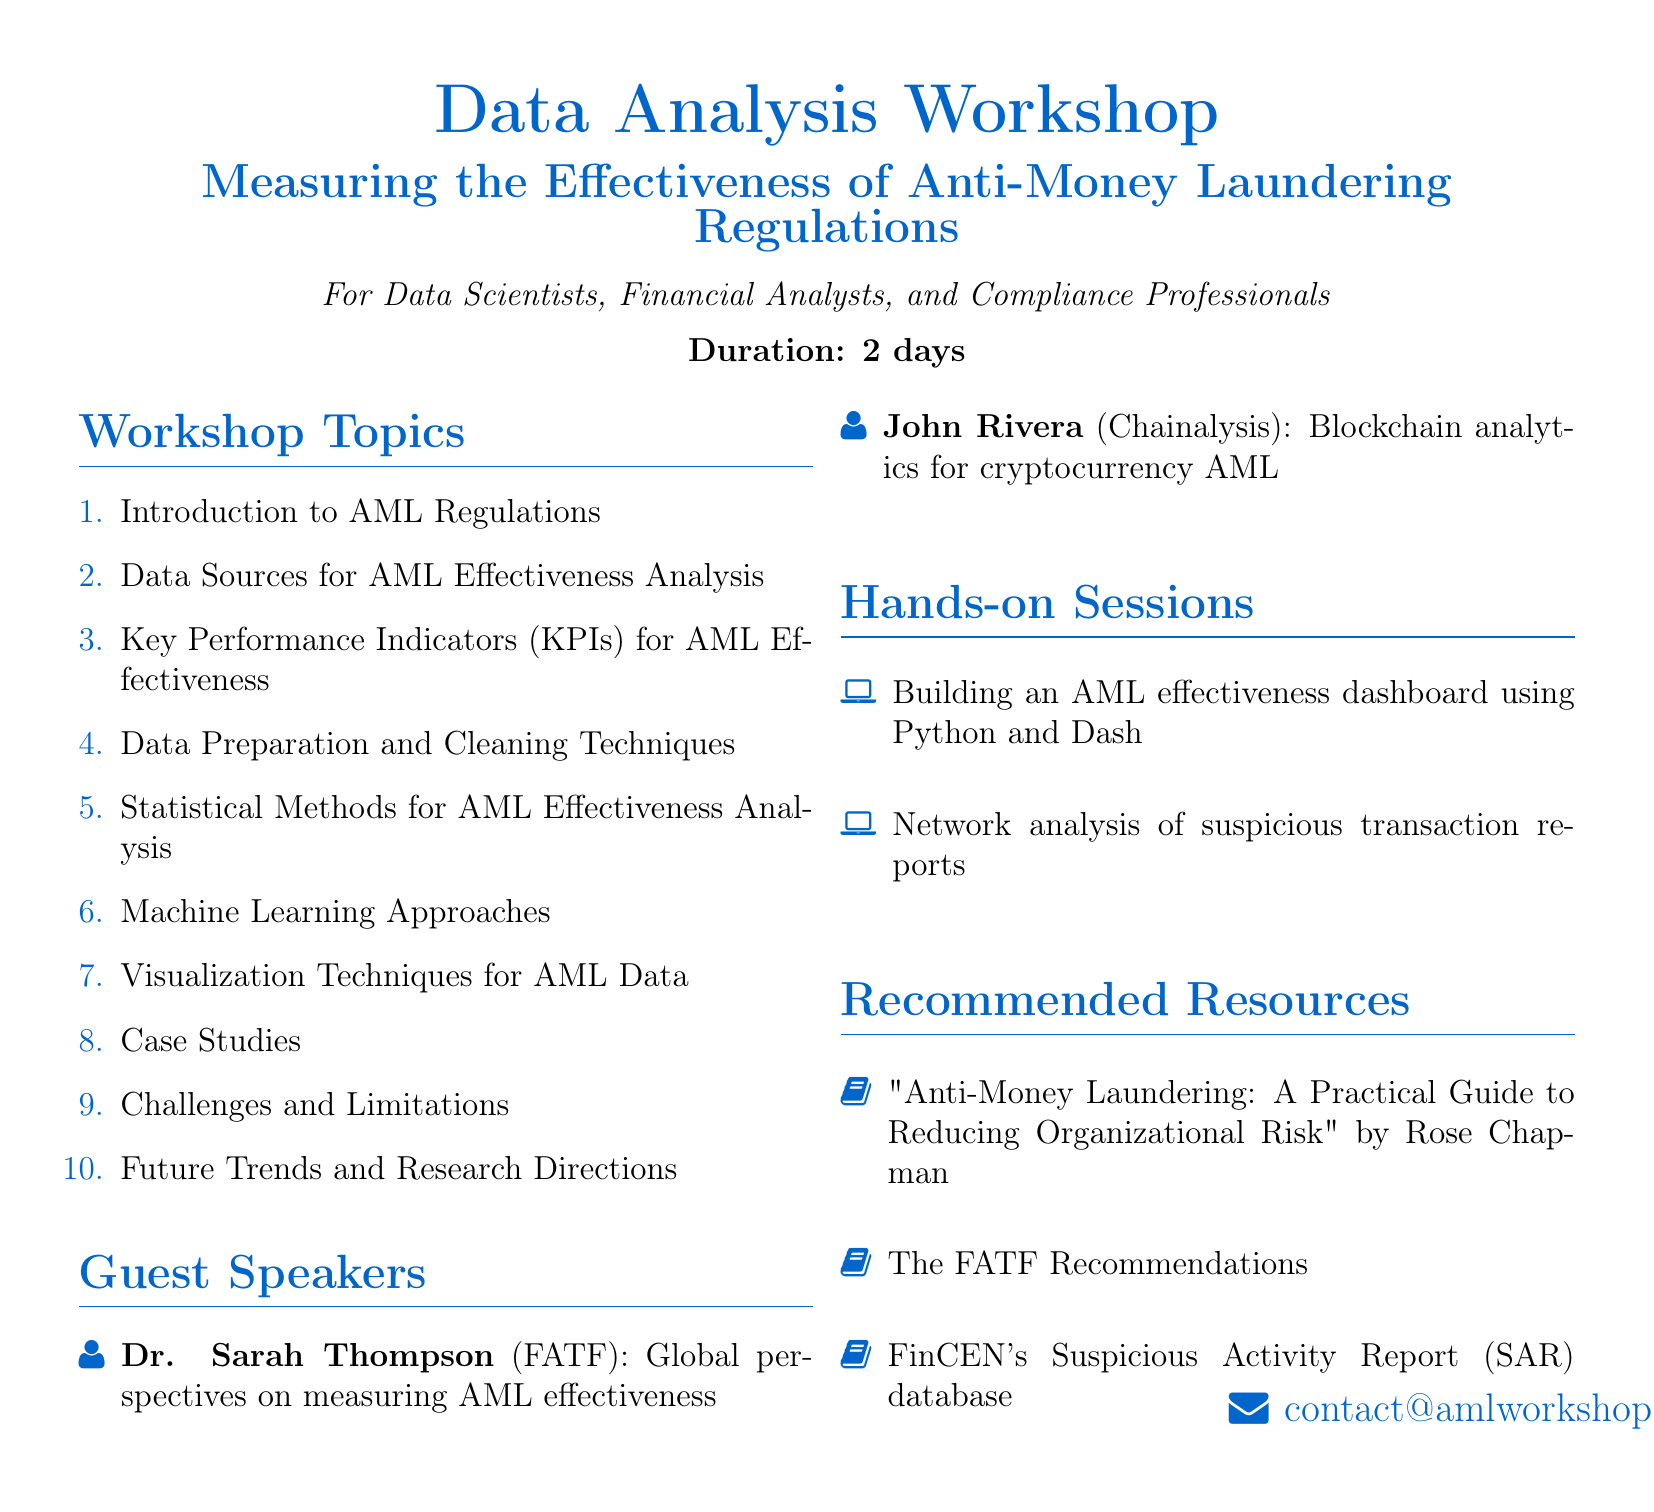What is the title of the workshop? The title of the workshop is stated at the beginning of the document.
Answer: Data Analysis Workshop: Measuring the Effectiveness of Anti-Money Laundering Regulations How many days is the workshop scheduled for? The duration of the workshop is specified in the document.
Answer: 2 days Who will be speaking from the Financial Action Task Force? The document lists guest speakers along with their affiliations and topics.
Answer: Dr. Sarah Thompson What is one of the key performance indicators for AML effectiveness? The document outlines various KPIs under a dedicated topic.
Answer: Number of successful prosecutions Which tool is used for building an AML effectiveness dashboard? The hands-on sessions section specifies the tools for each activity.
Answer: Python What is one challenge mentioned regarding AML data analysis? The challenges section enumerates potential issues in analyzing AML data.
Answer: Data quality issues in cross-border investigations Who is the author of the recommended book on reducing organizational risk? The recommended resources section lists books and their authors.
Answer: Rose Chapman What type of session involves network analysis? The hands-on sessions clarify the content of each session.
Answer: Network analysis of suspicious transaction reports 